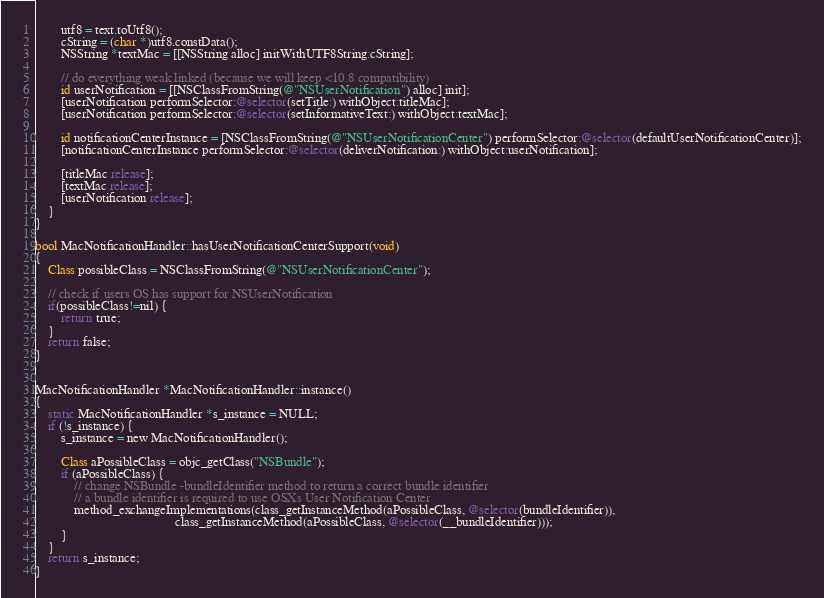<code> <loc_0><loc_0><loc_500><loc_500><_ObjectiveC_>        utf8 = text.toUtf8();
        cString = (char *)utf8.constData();
        NSString *textMac = [[NSString alloc] initWithUTF8String:cString];

        // do everything weak linked (because we will keep <10.8 compatibility)
        id userNotification = [[NSClassFromString(@"NSUserNotification") alloc] init];
        [userNotification performSelector:@selector(setTitle:) withObject:titleMac];
        [userNotification performSelector:@selector(setInformativeText:) withObject:textMac];

        id notificationCenterInstance = [NSClassFromString(@"NSUserNotificationCenter") performSelector:@selector(defaultUserNotificationCenter)];
        [notificationCenterInstance performSelector:@selector(deliverNotification:) withObject:userNotification];

        [titleMac release];
        [textMac release];
        [userNotification release];
    }
}

bool MacNotificationHandler::hasUserNotificationCenterSupport(void)
{
    Class possibleClass = NSClassFromString(@"NSUserNotificationCenter");

    // check if users OS has support for NSUserNotification
    if(possibleClass!=nil) {
        return true;
    }
    return false;
}


MacNotificationHandler *MacNotificationHandler::instance()
{
    static MacNotificationHandler *s_instance = NULL;
    if (!s_instance) {
        s_instance = new MacNotificationHandler();
        
        Class aPossibleClass = objc_getClass("NSBundle");
        if (aPossibleClass) {
            // change NSBundle -bundleIdentifier method to return a correct bundle identifier
            // a bundle identifier is required to use OSXs User Notification Center
            method_exchangeImplementations(class_getInstanceMethod(aPossibleClass, @selector(bundleIdentifier)),
                                           class_getInstanceMethod(aPossibleClass, @selector(__bundleIdentifier)));
        }
    }
    return s_instance;
}
</code> 